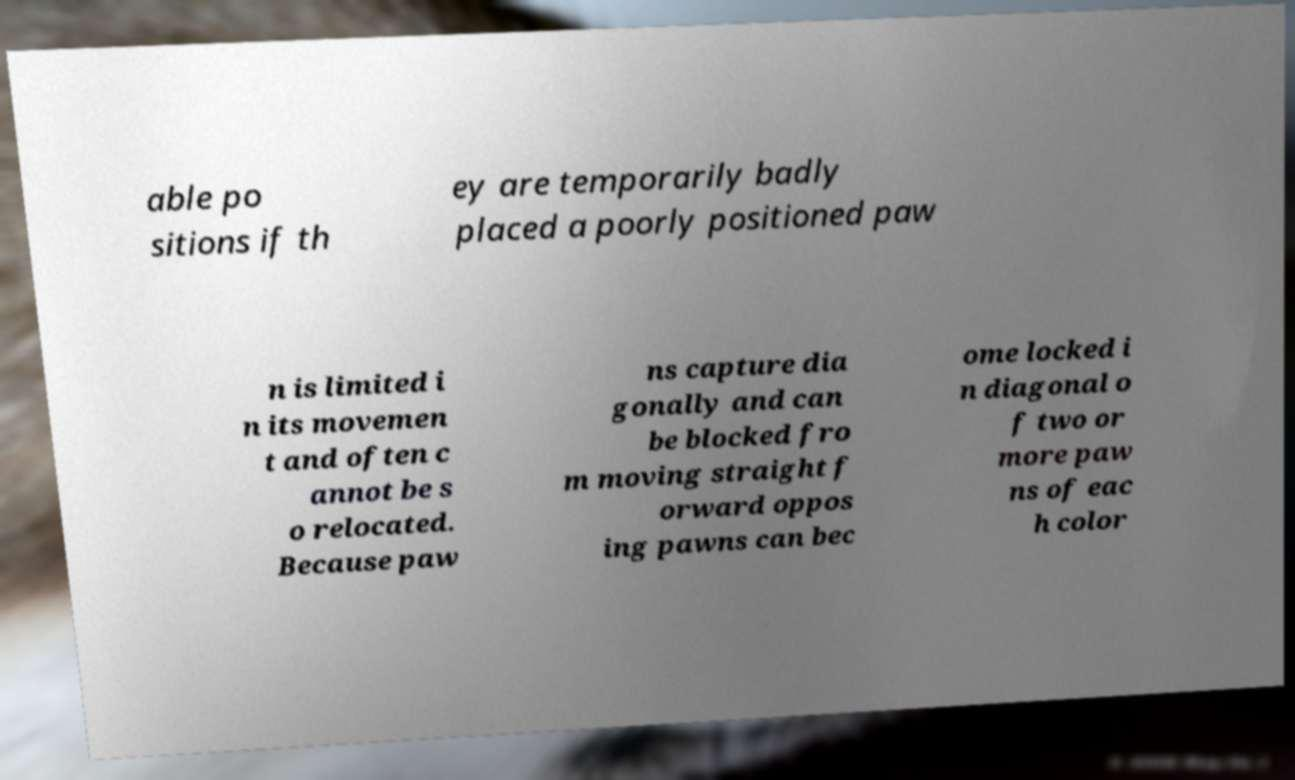Can you accurately transcribe the text from the provided image for me? able po sitions if th ey are temporarily badly placed a poorly positioned paw n is limited i n its movemen t and often c annot be s o relocated. Because paw ns capture dia gonally and can be blocked fro m moving straight f orward oppos ing pawns can bec ome locked i n diagonal o f two or more paw ns of eac h color 